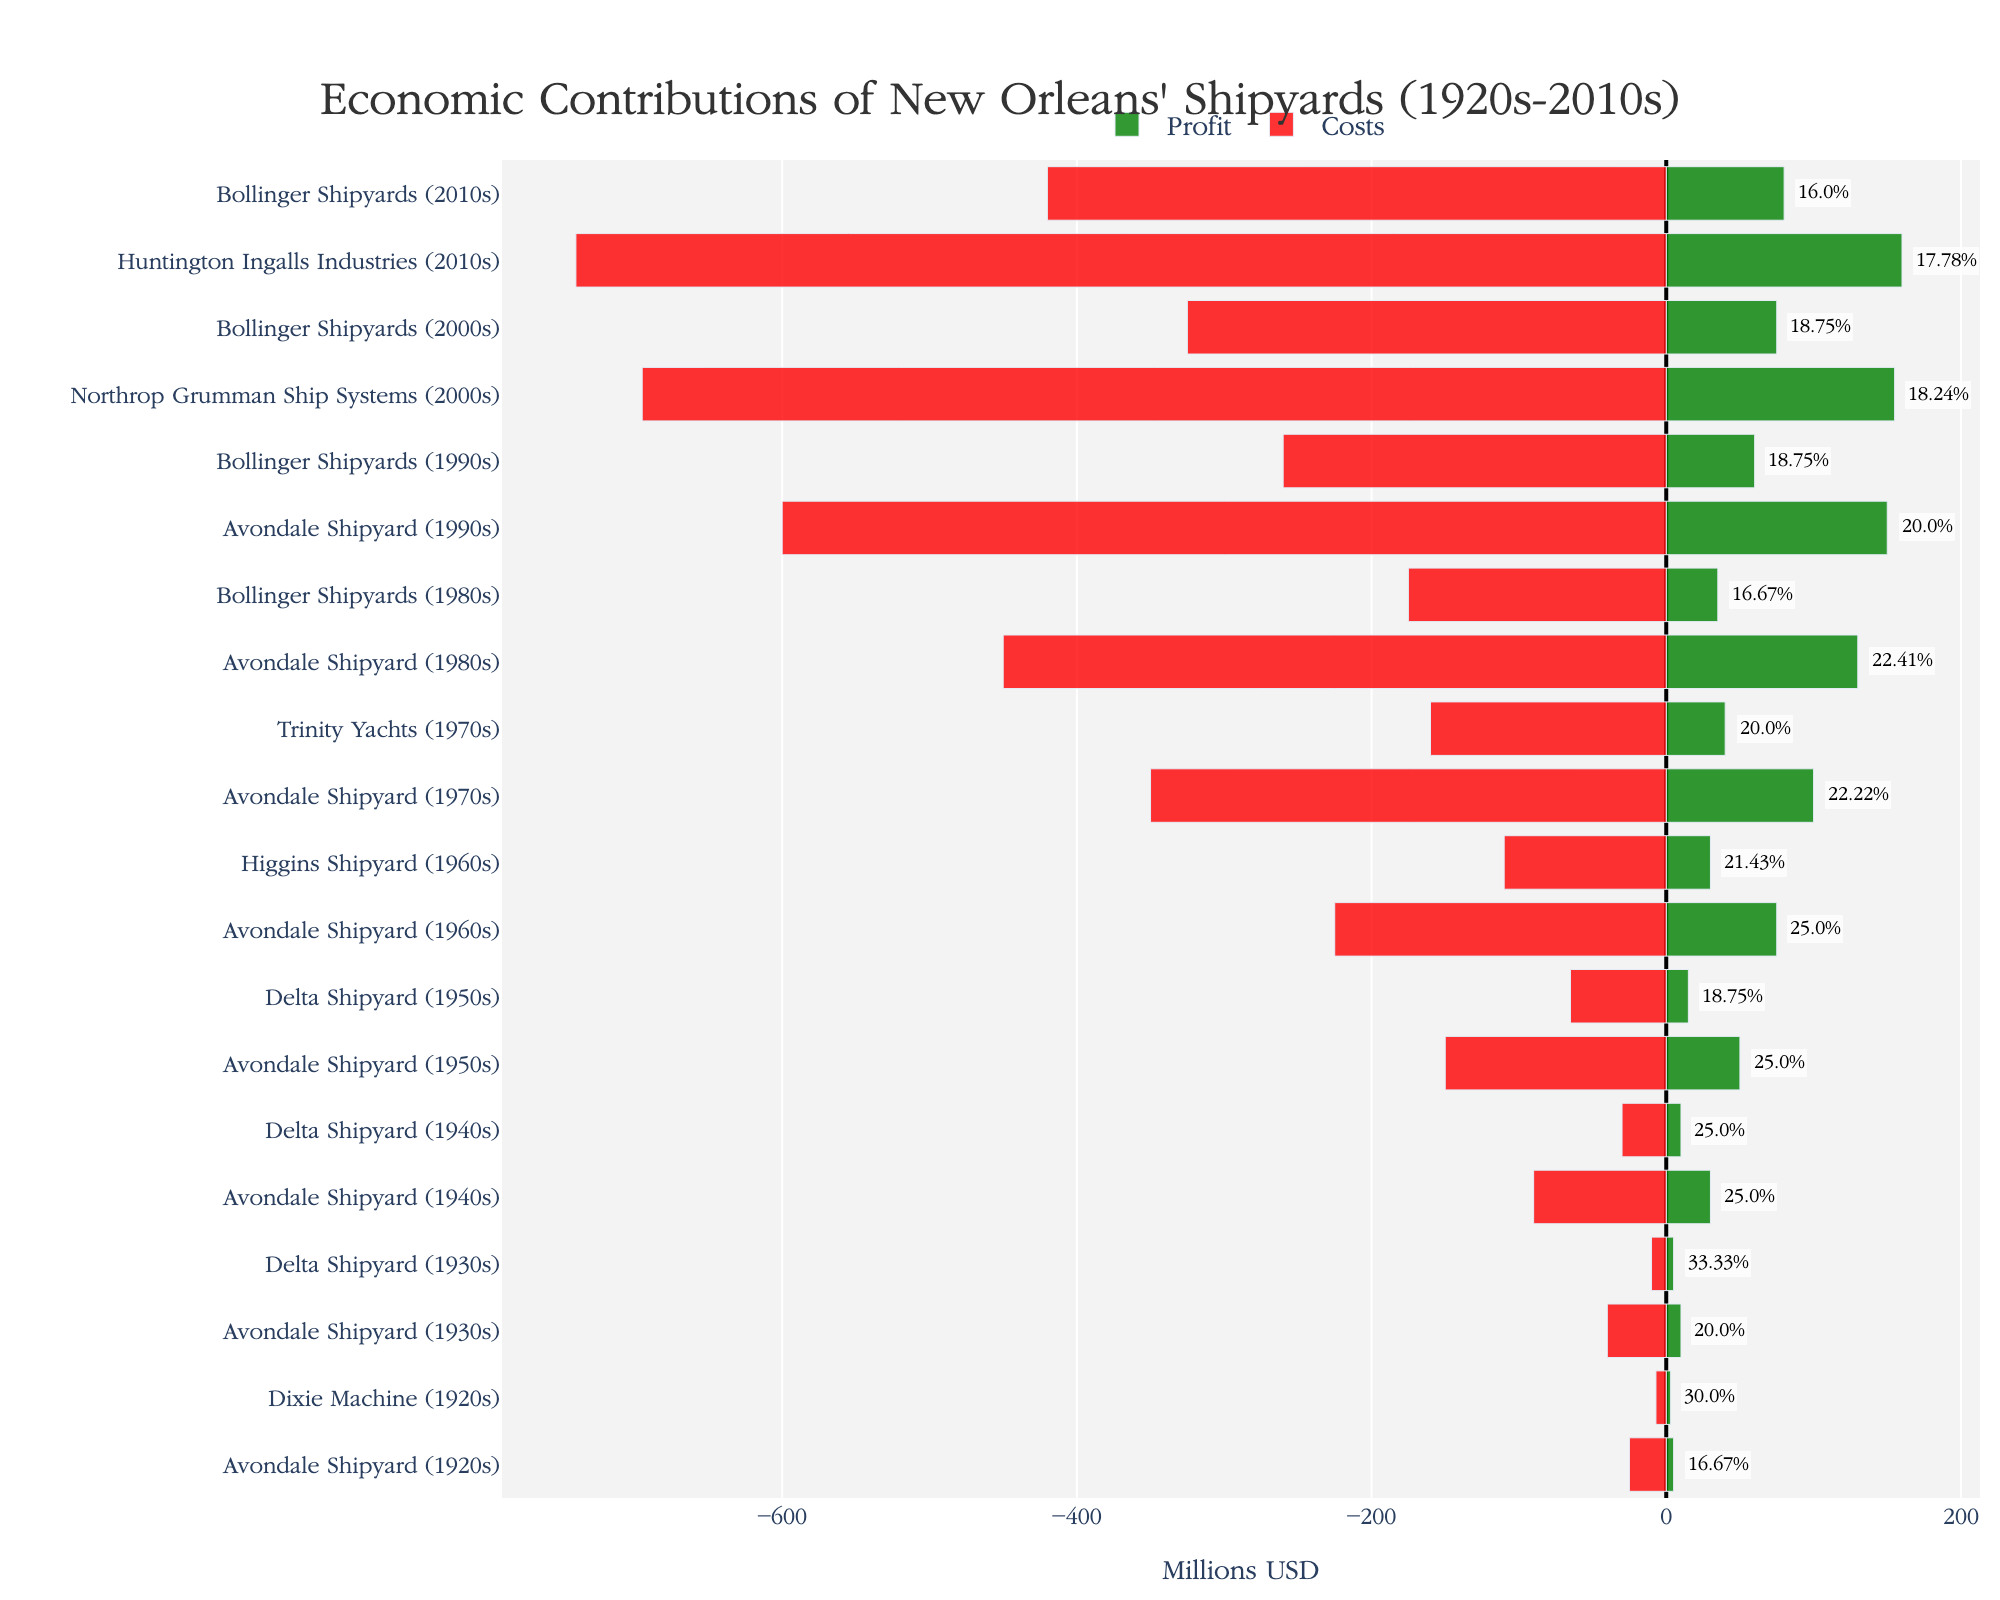What's the average profit margin for Bollinger Shipyards across all decades? First, identify the profit margins for Bollinger Shipyards: 16.67% (1980s), 18.75% (1990s), 18.75% (2000s), and 16.00% (2010s). Sum these percentages: 16.67 + 18.75 + 18.75 + 16.00 = 70.17. Divide by the number of data points, which is 4. So, the average is 70.17 / 4 = 17.54
Answer: 17.54% Which shipyard had the highest profit margin in the 1940s? In the 1940s, the profit margins are: Avondale Shipyard (25.00%) and Delta Shipyard (25.00%). Since both have the same profit margin, we can state that both had the highest profit margin in the 1940s.
Answer: Avondale Shipyard and Delta Shipyard What was the total revenue for Avondale Shipyard in the 1970s and 1980s combined? The revenue for Avondale Shipyard is $450M in the 1970s and $580M in the 1980s. Add both values: $450M + $580M = $1030M
Answer: $1030M Which decade had the highest total costs across all shipyards? Calculate the total costs per decade: 1920s: $25M + $7M = $32M, 1930s: $40M + $10M = $50M, 1940s: $90M + $30M = $120M, 1950s: $150M + $65M = $215M, 1960s: $225M + $110M = $335M, 1970s: $350M + $160M = $510M, 1980s: $450M + $175M = $625M, 1990s: $600M + $260M = $860M, 2000s: $695M + $325M = $1020M, 2010s: $740M + $420M = $1160M. The 2010s have the highest total costs.
Answer: 2010s Which shipyard had the least costs in the 1960s? In the 1960s, Higgins Shipyard had costs of $110M, and Avondale Shipyard had costs of $225M. The least costs were by Higgins Shipyard.
Answer: Higgins Shipyard By what percentage did the profit margin for Avondale Shipyard change from the 1960s to the 1970s? The profit margin for Avondale Shipyard was 25.00% in the 1960s and 22.22% in the 1970s. The change in percentage is 25.00% - 22.22% = 2.78%. The change is a decrease, so negative.
Answer: -2.78% Which decade had the largest difference in profit margins between shipyards? Calculate the differences for each decade: 1920s (30.00% - 16.67% = 13.33%), 1930s (33.33% - 20.00% = 13.33%), 1940s (25.00% - 25.00% = 0%), 1950s (25.00% - 18.75% = 6.25%), 1960s (25.00% - 21.43% = 3.57%), 1970s (22.22% - 20.00% = 2.22%), 1980s (22.41% - 16.67% = 5.74%), 1990s (20.00% - 18.75% = 1.25%), 2000s (18.75% - 18.24% = 0.51%), 2010s (17.78% - 16.00% = 1.78%). The largest difference occurs in the 1920s and 1930s, both with a 13.33% difference.
Answer: 1920s and 1930s In which decade did Avondale Shipyard have the highest revenue? The revenues for Avondale Shipyard by decade are: 1920s ($30M), 1930s ($50M), 1940s ($120M), 1950s ($200M), 1960s ($300M), 1970s ($450M), 1980s ($580M), 1990s ($750M). The highest revenue is in the 1990s with $750M.
Answer: 1990s 